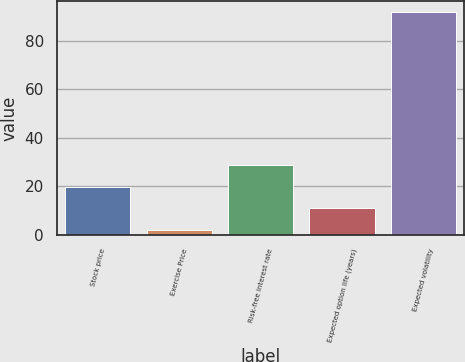Convert chart to OTSL. <chart><loc_0><loc_0><loc_500><loc_500><bar_chart><fcel>Stock price<fcel>Exercise Price<fcel>Risk-free interest rate<fcel>Expected option life (years)<fcel>Expected volatility<nl><fcel>19.75<fcel>1.75<fcel>28.75<fcel>10.75<fcel>91.7<nl></chart> 